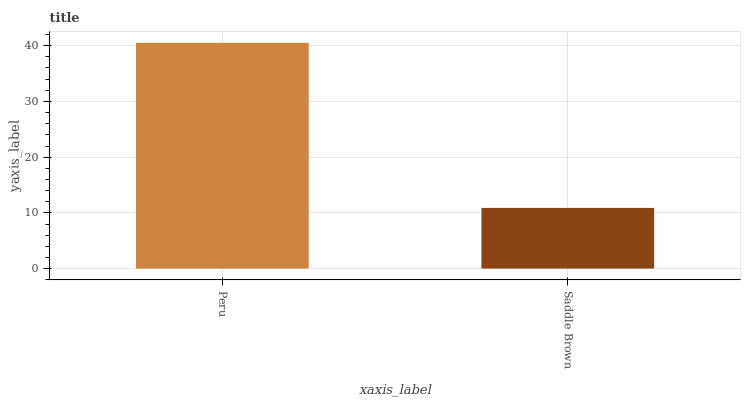Is Saddle Brown the minimum?
Answer yes or no. Yes. Is Peru the maximum?
Answer yes or no. Yes. Is Saddle Brown the maximum?
Answer yes or no. No. Is Peru greater than Saddle Brown?
Answer yes or no. Yes. Is Saddle Brown less than Peru?
Answer yes or no. Yes. Is Saddle Brown greater than Peru?
Answer yes or no. No. Is Peru less than Saddle Brown?
Answer yes or no. No. Is Peru the high median?
Answer yes or no. Yes. Is Saddle Brown the low median?
Answer yes or no. Yes. Is Saddle Brown the high median?
Answer yes or no. No. Is Peru the low median?
Answer yes or no. No. 